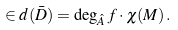Convert formula to latex. <formula><loc_0><loc_0><loc_500><loc_500>\in d ( \bar { D } ) = \deg _ { \hat { A } } f \cdot \chi ( M ) \, .</formula> 